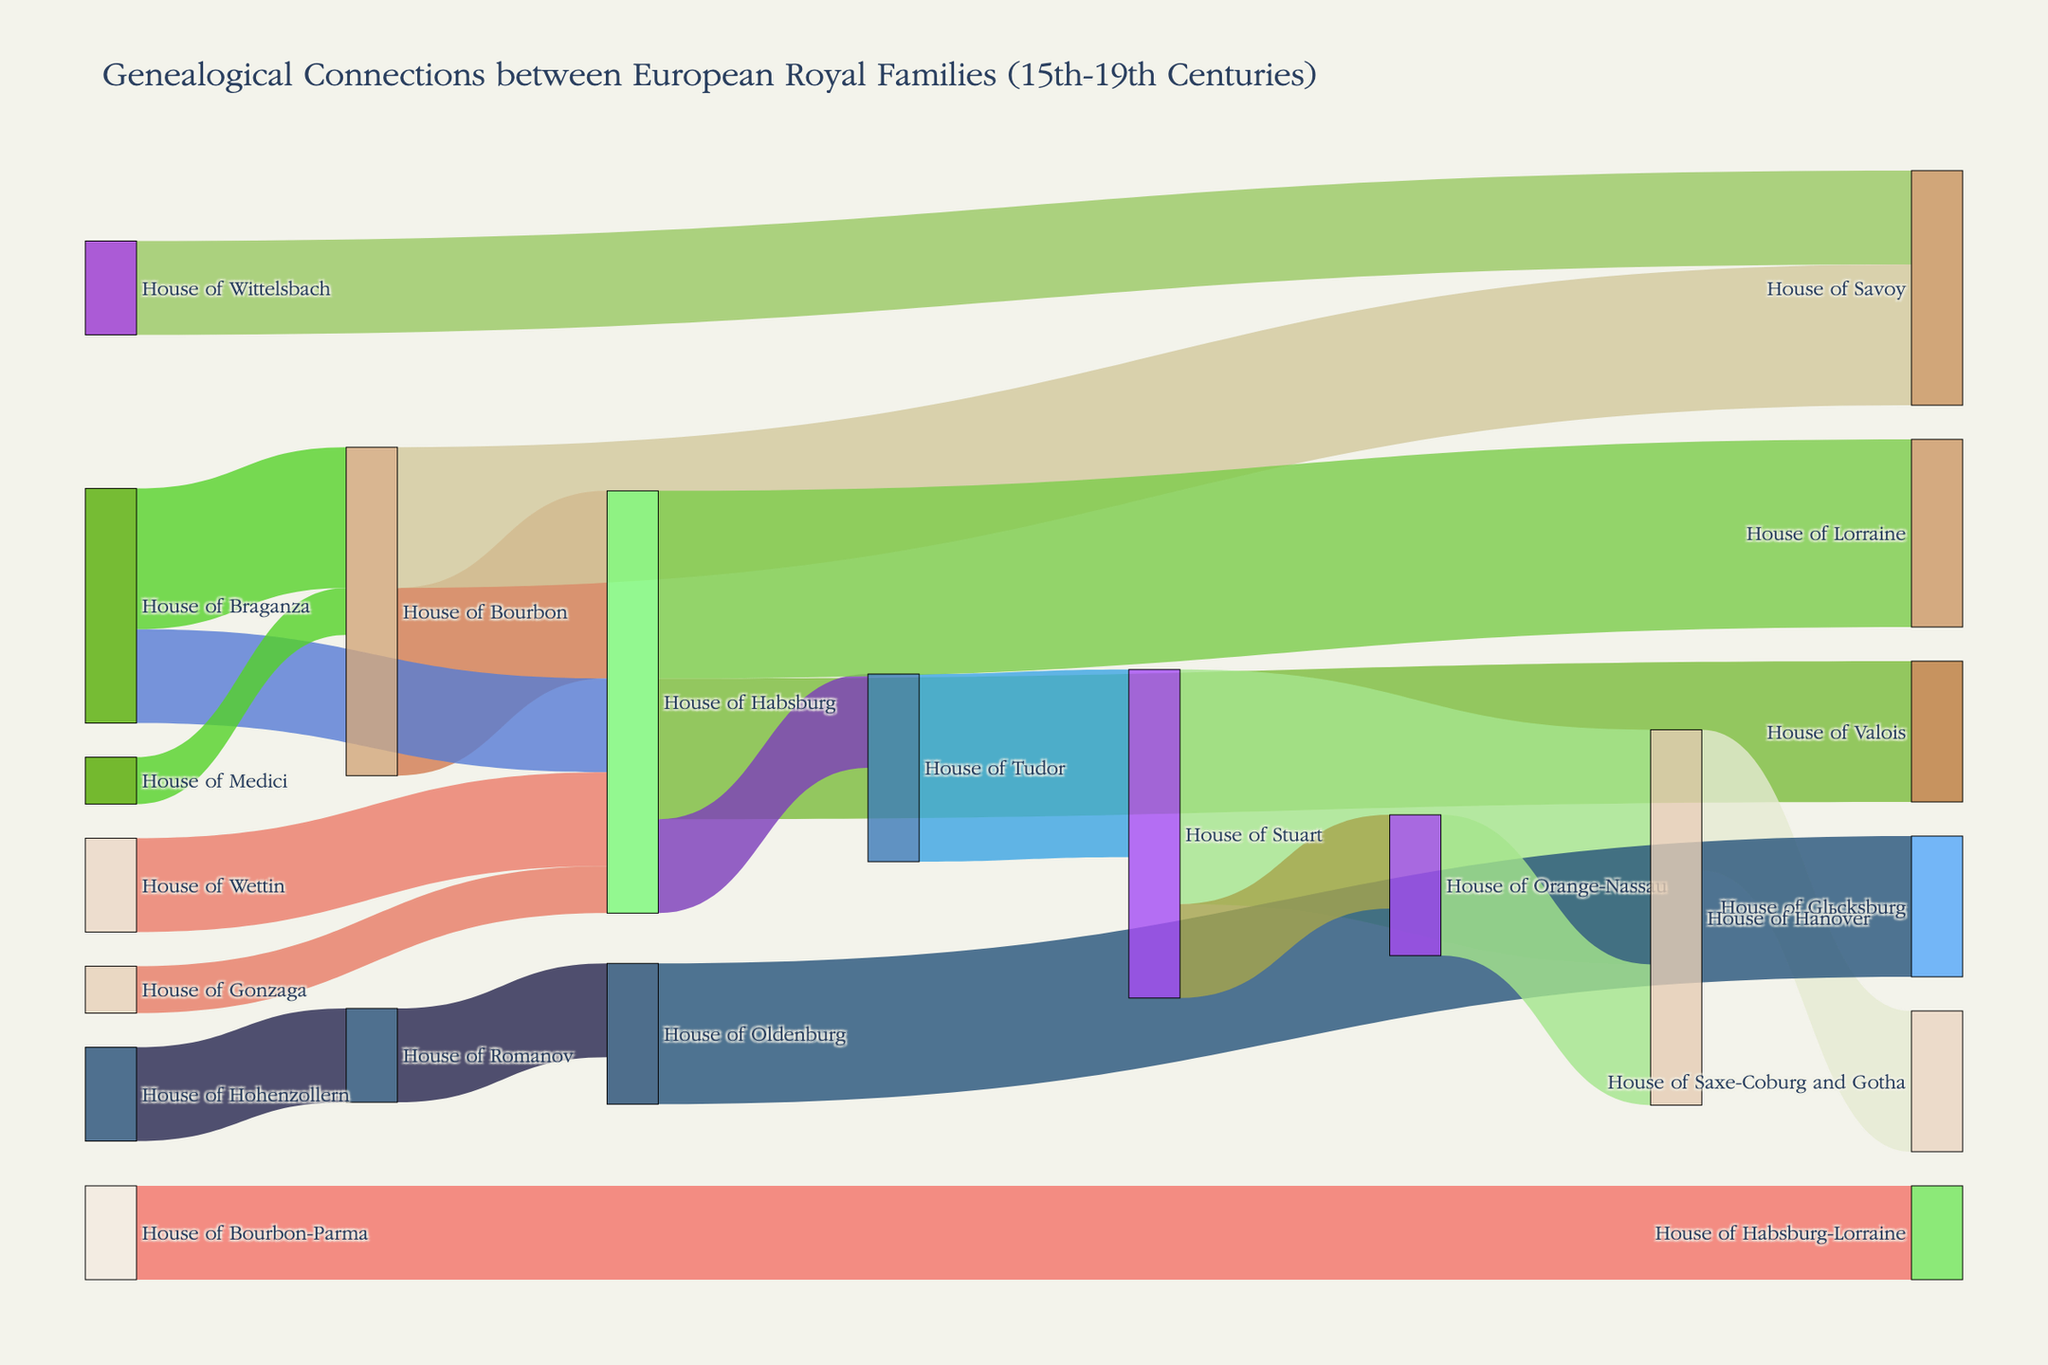What is the title of the Sankey Diagram? The title can be found at the top of the diagram. It usually summarizes what the diagram is about. In this case, it describes genealogical connections between European royal families from the 15th to the 19th centuries.
Answer: Genealogical Connections between European Royal Families (15th-19th Centuries) How many connections does the House of Habsburg have with other houses? Look at the number of lines (connections) originating from the House of Habsburg. Count the lines going to different target houses.
Answer: 5 Which house has the strongest connection to the House of Stuart? Identify the house that has the thickest and most number of lines connected to the House of Stuart. The thickness of the connection usually represents the strength.
Answer: House of Hanover How many royal houses are connected to the House of Bourbon? Count all the distinct connections (lines) originating from the House of Bourbon to different target houses.
Answer: 3 Which house has the largest number of connections in total? Look at the house which has both the largest number of outgoing and incoming lines combined. Consider both outgoing connections (sources) and incoming connections (targets).
Answer: House of Habsburg What is the total number of connections involving the House of Romanov? Find all lines connected to the House of Romanov, both incoming and outgoing, and sum them up.
Answer: 4 Between which two houses is the most significant single connection in terms of value (thickness)? Identify the single connection with the greatest value by looking at the thickness of the lines.
Answer: House of Stuart and House of Hanover Which house has genealogical ties with the House of Glücksburg? Observe the lines directed to or from the House of Glücksburg and identify the connecting house.
Answer: House of Oldenburg How many houses are connected to the House of Savoy? Count all distinct connections (both incoming and outgoing) related to the House of Savoy.
Answer: 2 